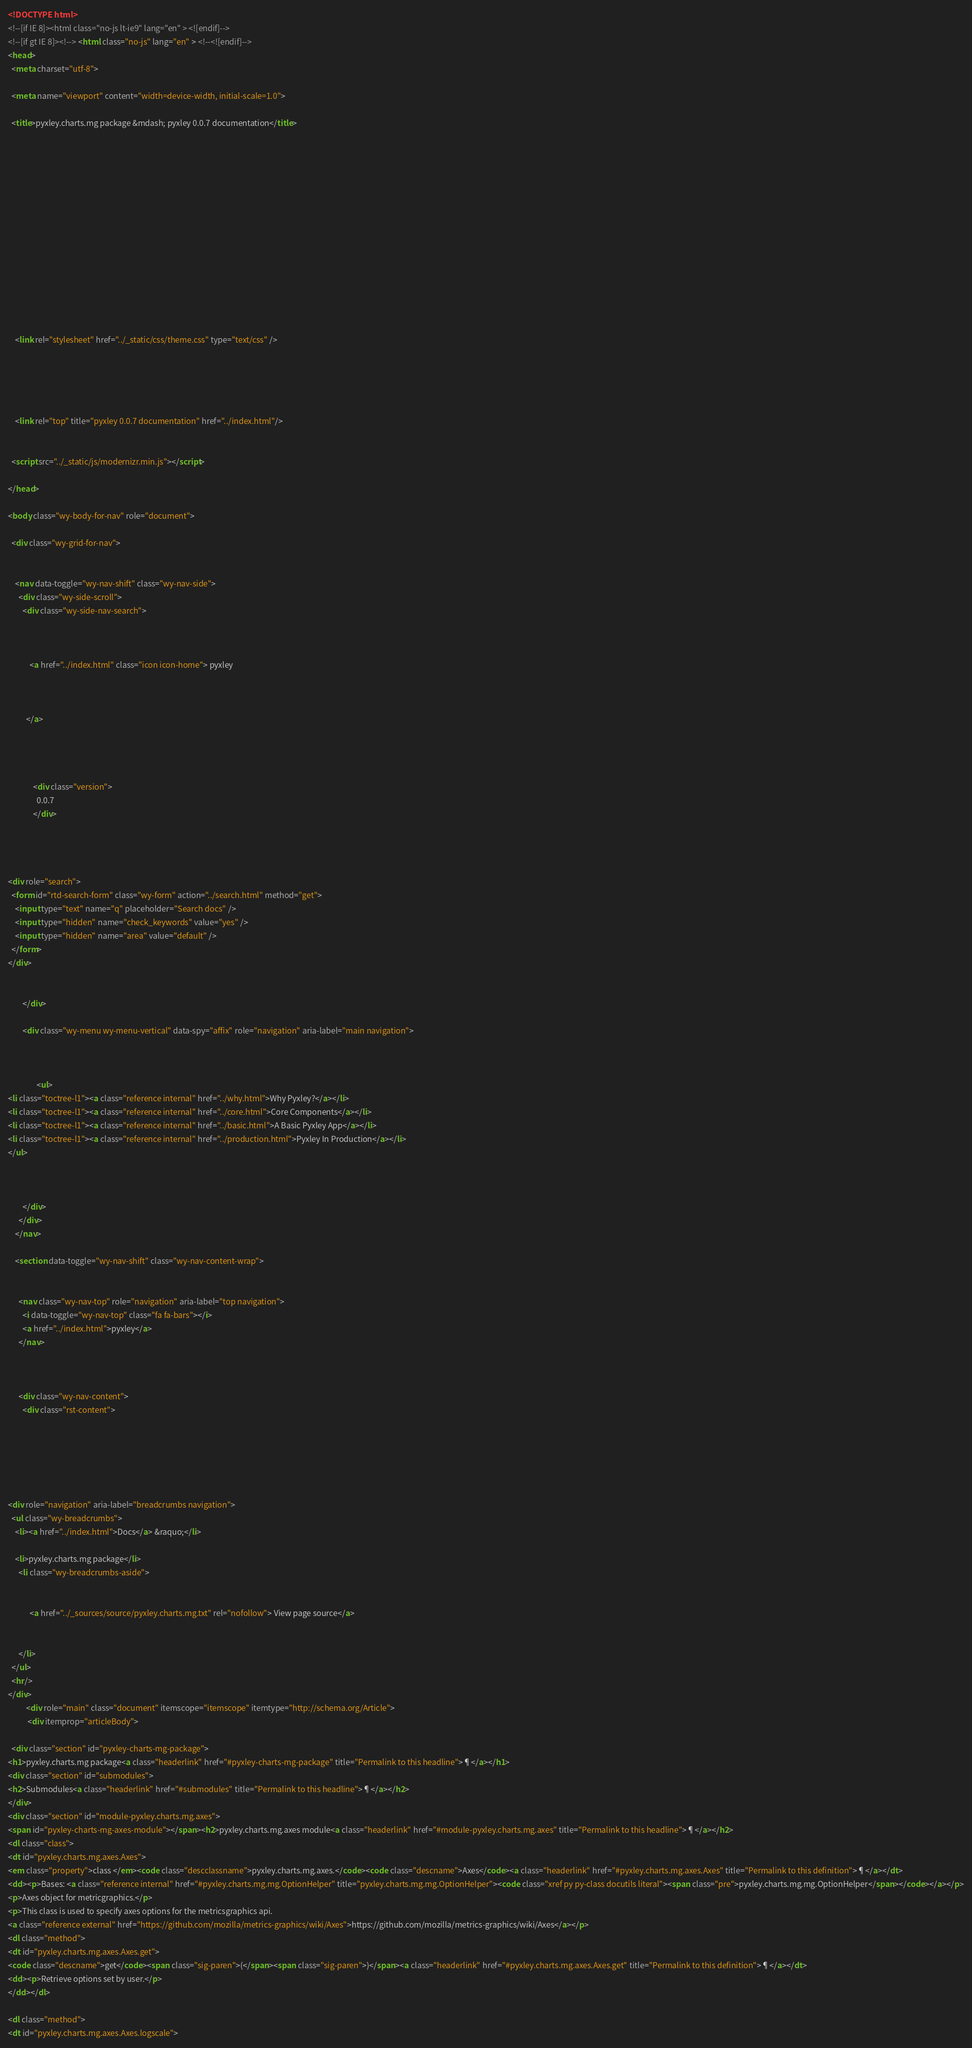<code> <loc_0><loc_0><loc_500><loc_500><_HTML_>

<!DOCTYPE html>
<!--[if IE 8]><html class="no-js lt-ie9" lang="en" > <![endif]-->
<!--[if gt IE 8]><!--> <html class="no-js" lang="en" > <!--<![endif]-->
<head>
  <meta charset="utf-8">
  
  <meta name="viewport" content="width=device-width, initial-scale=1.0">
  
  <title>pyxley.charts.mg package &mdash; pyxley 0.0.7 documentation</title>
  

  
  

  

  
  
    

  

  
  
    <link rel="stylesheet" href="../_static/css/theme.css" type="text/css" />
  

  

  
    <link rel="top" title="pyxley 0.0.7 documentation" href="../index.html"/> 

  
  <script src="../_static/js/modernizr.min.js"></script>

</head>

<body class="wy-body-for-nav" role="document">

  <div class="wy-grid-for-nav">

    
    <nav data-toggle="wy-nav-shift" class="wy-nav-side">
      <div class="wy-side-scroll">
        <div class="wy-side-nav-search">
          

          
            <a href="../index.html" class="icon icon-home"> pyxley
          

          
          </a>

          
            
            
              <div class="version">
                0.0.7
              </div>
            
          

          
<div role="search">
  <form id="rtd-search-form" class="wy-form" action="../search.html" method="get">
    <input type="text" name="q" placeholder="Search docs" />
    <input type="hidden" name="check_keywords" value="yes" />
    <input type="hidden" name="area" value="default" />
  </form>
</div>

          
        </div>

        <div class="wy-menu wy-menu-vertical" data-spy="affix" role="navigation" aria-label="main navigation">
          
            
            
                <ul>
<li class="toctree-l1"><a class="reference internal" href="../why.html">Why Pyxley?</a></li>
<li class="toctree-l1"><a class="reference internal" href="../core.html">Core Components</a></li>
<li class="toctree-l1"><a class="reference internal" href="../basic.html">A Basic Pyxley App</a></li>
<li class="toctree-l1"><a class="reference internal" href="../production.html">Pyxley In Production</a></li>
</ul>

            
          
        </div>
      </div>
    </nav>

    <section data-toggle="wy-nav-shift" class="wy-nav-content-wrap">

      
      <nav class="wy-nav-top" role="navigation" aria-label="top navigation">
        <i data-toggle="wy-nav-top" class="fa fa-bars"></i>
        <a href="../index.html">pyxley</a>
      </nav>


      
      <div class="wy-nav-content">
        <div class="rst-content">
          





<div role="navigation" aria-label="breadcrumbs navigation">
  <ul class="wy-breadcrumbs">
    <li><a href="../index.html">Docs</a> &raquo;</li>
      
    <li>pyxley.charts.mg package</li>
      <li class="wy-breadcrumbs-aside">
        
          
            <a href="../_sources/source/pyxley.charts.mg.txt" rel="nofollow"> View page source</a>
          
        
      </li>
  </ul>
  <hr/>
</div>
          <div role="main" class="document" itemscope="itemscope" itemtype="http://schema.org/Article">
           <div itemprop="articleBody">
            
  <div class="section" id="pyxley-charts-mg-package">
<h1>pyxley.charts.mg package<a class="headerlink" href="#pyxley-charts-mg-package" title="Permalink to this headline">¶</a></h1>
<div class="section" id="submodules">
<h2>Submodules<a class="headerlink" href="#submodules" title="Permalink to this headline">¶</a></h2>
</div>
<div class="section" id="module-pyxley.charts.mg.axes">
<span id="pyxley-charts-mg-axes-module"></span><h2>pyxley.charts.mg.axes module<a class="headerlink" href="#module-pyxley.charts.mg.axes" title="Permalink to this headline">¶</a></h2>
<dl class="class">
<dt id="pyxley.charts.mg.axes.Axes">
<em class="property">class </em><code class="descclassname">pyxley.charts.mg.axes.</code><code class="descname">Axes</code><a class="headerlink" href="#pyxley.charts.mg.axes.Axes" title="Permalink to this definition">¶</a></dt>
<dd><p>Bases: <a class="reference internal" href="#pyxley.charts.mg.mg.OptionHelper" title="pyxley.charts.mg.mg.OptionHelper"><code class="xref py py-class docutils literal"><span class="pre">pyxley.charts.mg.mg.OptionHelper</span></code></a></p>
<p>Axes object for metricgraphics.</p>
<p>This class is used to specify axes options for the metricsgraphics api.
<a class="reference external" href="https://github.com/mozilla/metrics-graphics/wiki/Axes">https://github.com/mozilla/metrics-graphics/wiki/Axes</a></p>
<dl class="method">
<dt id="pyxley.charts.mg.axes.Axes.get">
<code class="descname">get</code><span class="sig-paren">(</span><span class="sig-paren">)</span><a class="headerlink" href="#pyxley.charts.mg.axes.Axes.get" title="Permalink to this definition">¶</a></dt>
<dd><p>Retrieve options set by user.</p>
</dd></dl>

<dl class="method">
<dt id="pyxley.charts.mg.axes.Axes.logscale"></code> 